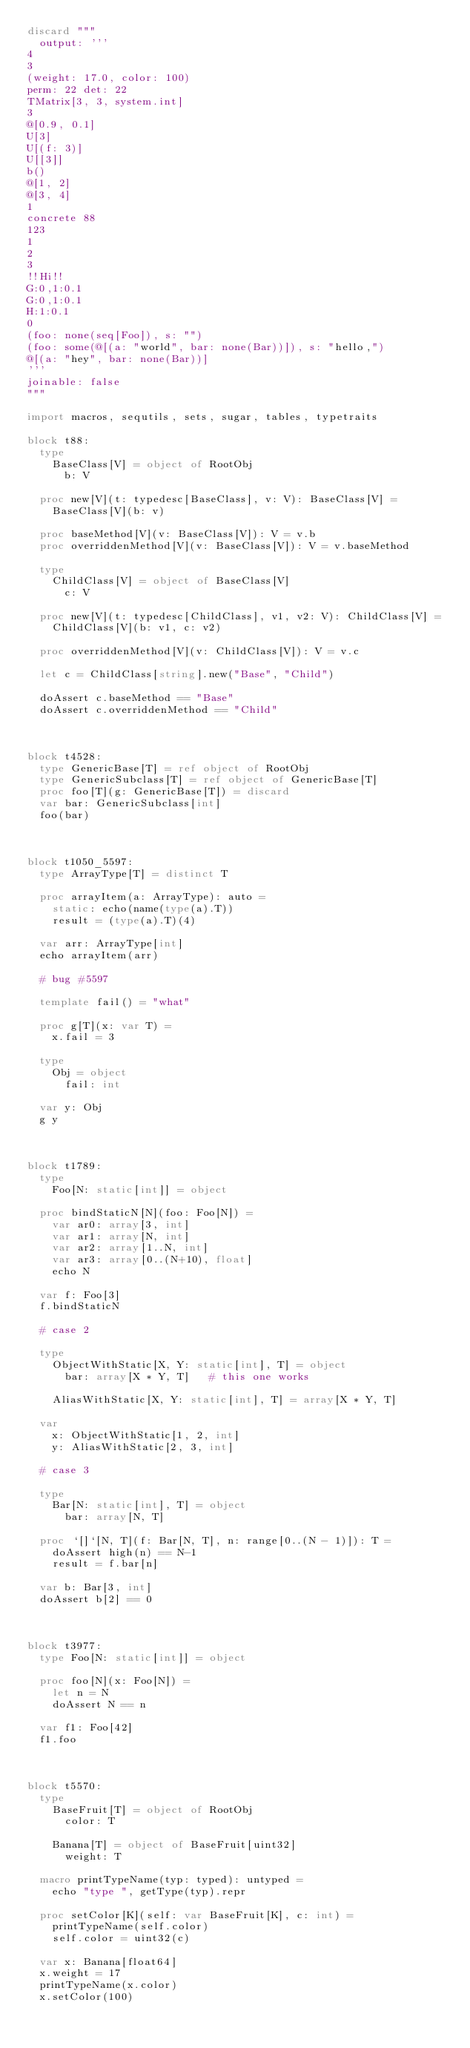<code> <loc_0><loc_0><loc_500><loc_500><_Nim_>discard """
  output: '''
4
3
(weight: 17.0, color: 100)
perm: 22 det: 22
TMatrix[3, 3, system.int]
3
@[0.9, 0.1]
U[3]
U[(f: 3)]
U[[3]]
b()
@[1, 2]
@[3, 4]
1
concrete 88
123
1
2
3
!!Hi!!
G:0,1:0.1
G:0,1:0.1
H:1:0.1
0
(foo: none(seq[Foo]), s: "")
(foo: some(@[(a: "world", bar: none(Bar))]), s: "hello,")
@[(a: "hey", bar: none(Bar))]
'''
joinable: false
"""

import macros, sequtils, sets, sugar, tables, typetraits

block t88:
  type
    BaseClass[V] = object of RootObj
      b: V

  proc new[V](t: typedesc[BaseClass], v: V): BaseClass[V] =
    BaseClass[V](b: v)

  proc baseMethod[V](v: BaseClass[V]): V = v.b
  proc overriddenMethod[V](v: BaseClass[V]): V = v.baseMethod

  type
    ChildClass[V] = object of BaseClass[V]
      c: V

  proc new[V](t: typedesc[ChildClass], v1, v2: V): ChildClass[V] =
    ChildClass[V](b: v1, c: v2)

  proc overriddenMethod[V](v: ChildClass[V]): V = v.c

  let c = ChildClass[string].new("Base", "Child")

  doAssert c.baseMethod == "Base"
  doAssert c.overriddenMethod == "Child"



block t4528:
  type GenericBase[T] = ref object of RootObj
  type GenericSubclass[T] = ref object of GenericBase[T]
  proc foo[T](g: GenericBase[T]) = discard
  var bar: GenericSubclass[int]
  foo(bar)



block t1050_5597:
  type ArrayType[T] = distinct T

  proc arrayItem(a: ArrayType): auto =
    static: echo(name(type(a).T))
    result = (type(a).T)(4)

  var arr: ArrayType[int]
  echo arrayItem(arr)

  # bug #5597

  template fail() = "what"

  proc g[T](x: var T) =
    x.fail = 3

  type
    Obj = object
      fail: int

  var y: Obj
  g y



block t1789:
  type
    Foo[N: static[int]] = object

  proc bindStaticN[N](foo: Foo[N]) =
    var ar0: array[3, int]
    var ar1: array[N, int]
    var ar2: array[1..N, int]
    var ar3: array[0..(N+10), float]
    echo N

  var f: Foo[3]
  f.bindStaticN

  # case 2

  type
    ObjectWithStatic[X, Y: static[int], T] = object
      bar: array[X * Y, T]   # this one works

    AliasWithStatic[X, Y: static[int], T] = array[X * Y, T]

  var
    x: ObjectWithStatic[1, 2, int]
    y: AliasWithStatic[2, 3, int]

  # case 3

  type
    Bar[N: static[int], T] = object
      bar: array[N, T]

  proc `[]`[N, T](f: Bar[N, T], n: range[0..(N - 1)]): T =
    doAssert high(n) == N-1
    result = f.bar[n]

  var b: Bar[3, int]
  doAssert b[2] == 0



block t3977:
  type Foo[N: static[int]] = object

  proc foo[N](x: Foo[N]) =
    let n = N
    doAssert N == n

  var f1: Foo[42]
  f1.foo



block t5570:
  type
    BaseFruit[T] = object of RootObj
      color: T

    Banana[T] = object of BaseFruit[uint32]
      weight: T

  macro printTypeName(typ: typed): untyped =
    echo "type ", getType(typ).repr

  proc setColor[K](self: var BaseFruit[K], c: int) =
    printTypeName(self.color)
    self.color = uint32(c)

  var x: Banana[float64]
  x.weight = 17
  printTypeName(x.color)
  x.setColor(100)</code> 